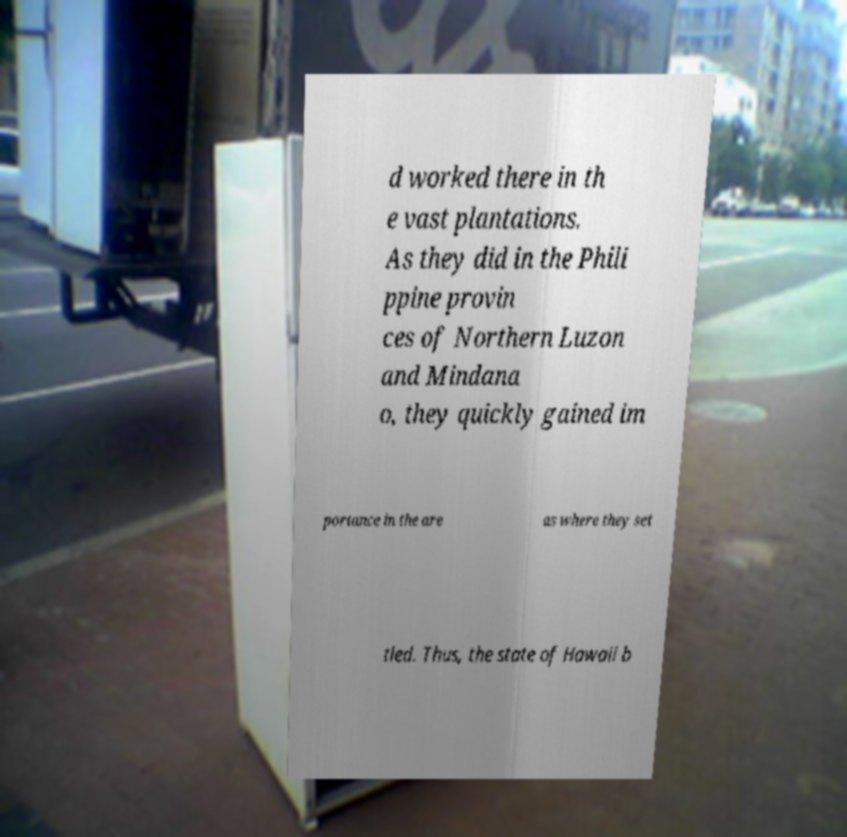Could you assist in decoding the text presented in this image and type it out clearly? d worked there in th e vast plantations. As they did in the Phili ppine provin ces of Northern Luzon and Mindana o, they quickly gained im portance in the are as where they set tled. Thus, the state of Hawaii b 